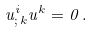<formula> <loc_0><loc_0><loc_500><loc_500>u ^ { i } _ { ; \, k } u ^ { k } = 0 \, .</formula> 